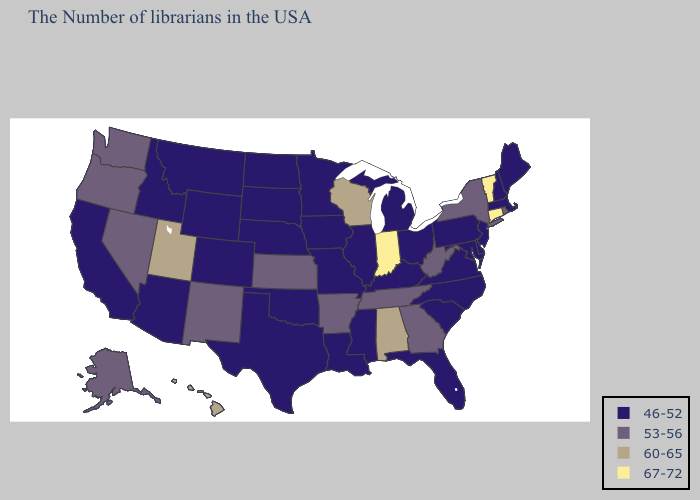What is the value of Mississippi?
Answer briefly. 46-52. What is the highest value in states that border Tennessee?
Be succinct. 60-65. What is the value of Alabama?
Answer briefly. 60-65. What is the highest value in the Northeast ?
Be succinct. 67-72. Is the legend a continuous bar?
Answer briefly. No. Does Arkansas have the highest value in the USA?
Concise answer only. No. What is the highest value in states that border Wyoming?
Write a very short answer. 60-65. What is the value of Delaware?
Be succinct. 46-52. Which states have the lowest value in the USA?
Short answer required. Maine, Massachusetts, New Hampshire, New Jersey, Delaware, Maryland, Pennsylvania, Virginia, North Carolina, South Carolina, Ohio, Florida, Michigan, Kentucky, Illinois, Mississippi, Louisiana, Missouri, Minnesota, Iowa, Nebraska, Oklahoma, Texas, South Dakota, North Dakota, Wyoming, Colorado, Montana, Arizona, Idaho, California. Name the states that have a value in the range 60-65?
Answer briefly. Alabama, Wisconsin, Utah, Hawaii. What is the highest value in the MidWest ?
Short answer required. 67-72. Does Alabama have a lower value than Indiana?
Quick response, please. Yes. Name the states that have a value in the range 53-56?
Answer briefly. Rhode Island, New York, West Virginia, Georgia, Tennessee, Arkansas, Kansas, New Mexico, Nevada, Washington, Oregon, Alaska. Name the states that have a value in the range 53-56?
Quick response, please. Rhode Island, New York, West Virginia, Georgia, Tennessee, Arkansas, Kansas, New Mexico, Nevada, Washington, Oregon, Alaska. What is the value of South Dakota?
Write a very short answer. 46-52. 